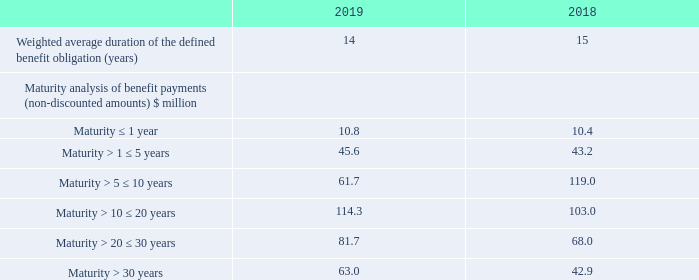9. Pensions continued
Defined benefit plans continued
iii) Amount, timing and uncertainty of future cash flows continued
The liability has the following duration and maturity:
What information of the liability does the table provide? Duration and maturity. What was the Weighted average duration of the defined benefit obligation (years) in 2019? 14. What are the categories of maturity used in the Maturity analysis of benefit payments (non-discounted amounts)? Maturity ≤ 1 year, maturity > 1 ≤ 5 years, maturity > 5 ≤ 10 years, maturity > 10 ≤ 20 years, maturity > 20 ≤ 30 years, maturity > 30 years. In which year was the Weighted average duration of the defined benefit obligation (years) larger? 15>14
Answer: 2018. What was the change in the benefit payments (non-discounted amounts) for maturity > 30 years?
Answer scale should be: million. 63.0-42.9
Answer: 20.1. What was the percentage change in the benefit payments (non-discounted amounts) for maturity > 30 years?
Answer scale should be: percent. (63.0-42.9)/42.9
Answer: 46.85. 